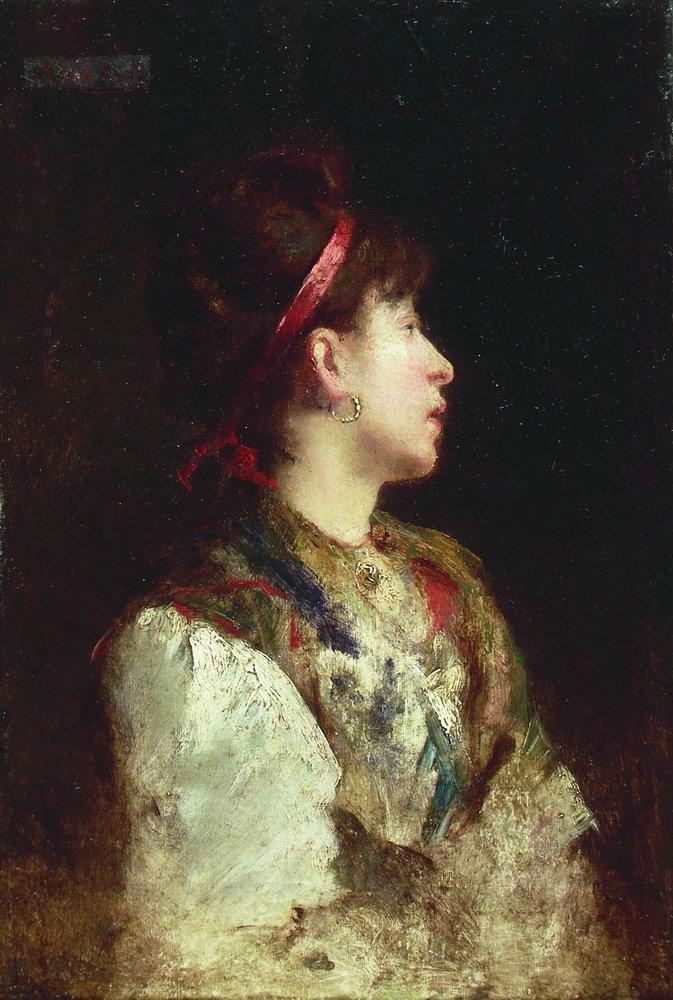If the woman could speak, what would she say? "I have seen many seasons come and go, each bringing its own colors and stories. This shawl I wear is not just fabric; it is woven with memories of joyful mornings and quiet, contemplative evenings. The world may see only the surface of our lives, but it is the quiet moments, the whispered thoughts, and the silent reflections that truly define us." 